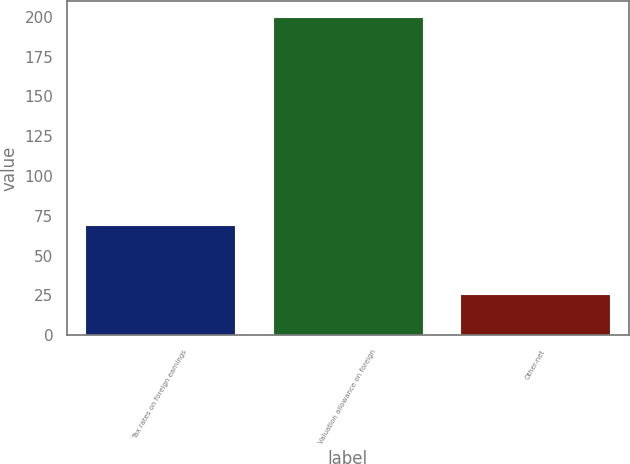Convert chart to OTSL. <chart><loc_0><loc_0><loc_500><loc_500><bar_chart><fcel>Tax rates on foreign earnings<fcel>Valuation allowance on foreign<fcel>Other-net<nl><fcel>69<fcel>200<fcel>26<nl></chart> 